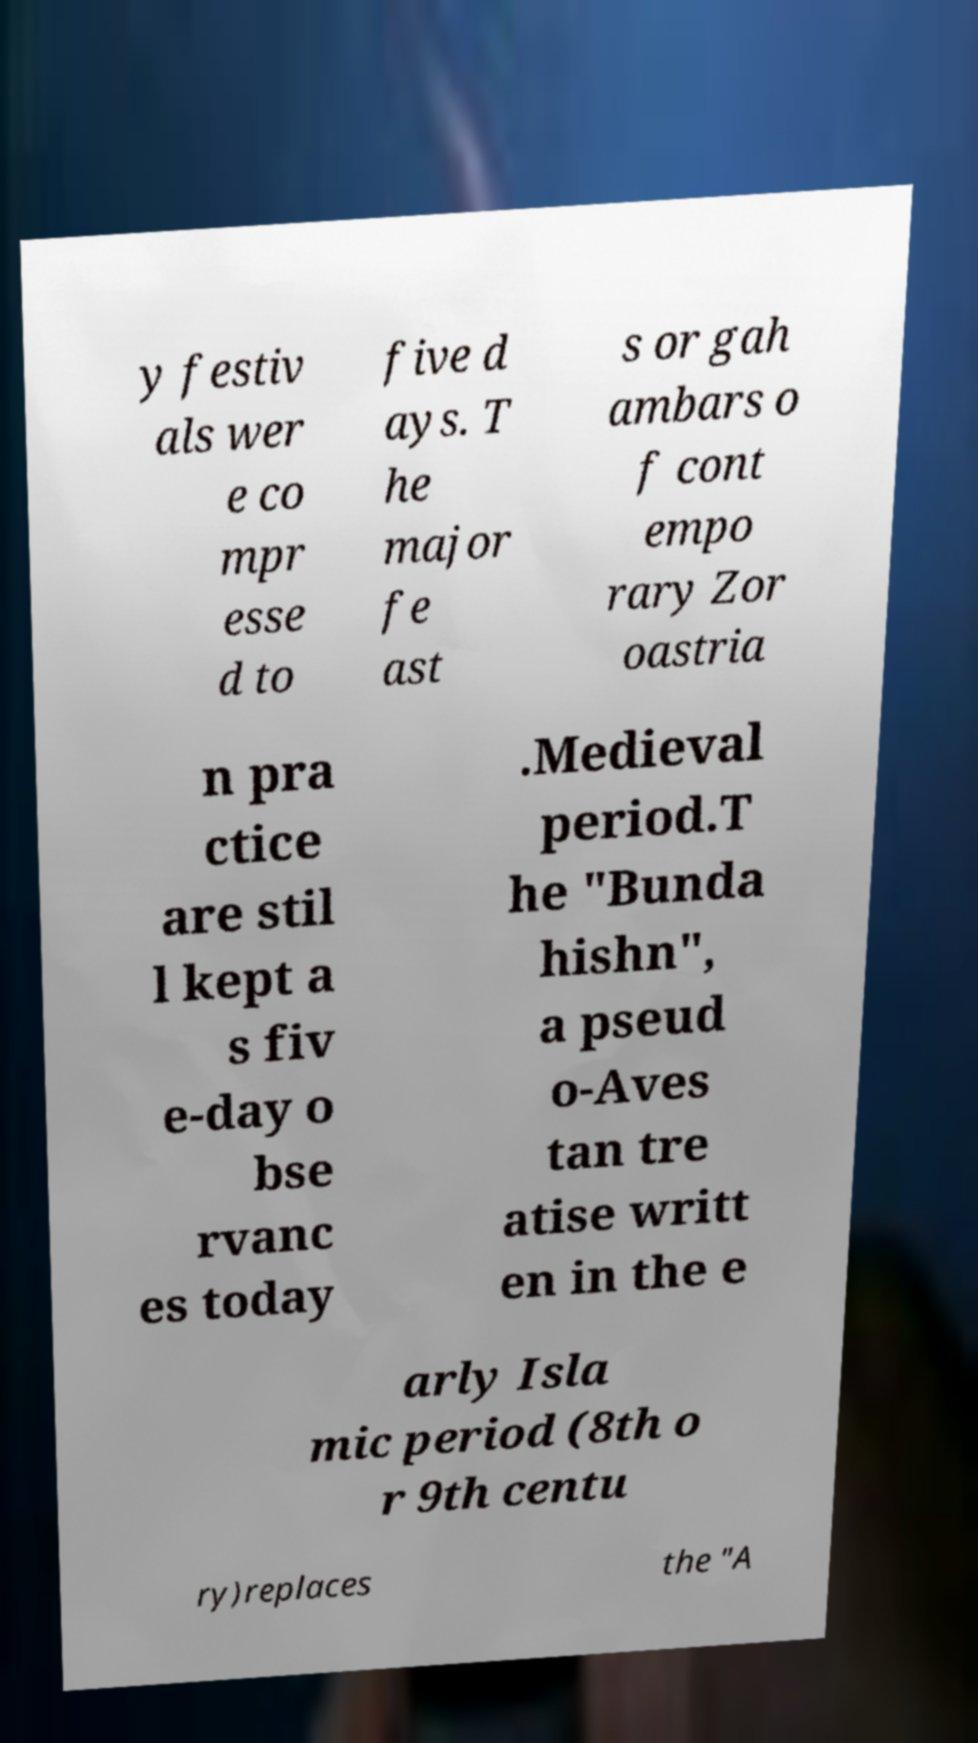Could you assist in decoding the text presented in this image and type it out clearly? y festiv als wer e co mpr esse d to five d ays. T he major fe ast s or gah ambars o f cont empo rary Zor oastria n pra ctice are stil l kept a s fiv e-day o bse rvanc es today .Medieval period.T he "Bunda hishn", a pseud o-Aves tan tre atise writt en in the e arly Isla mic period (8th o r 9th centu ry)replaces the "A 